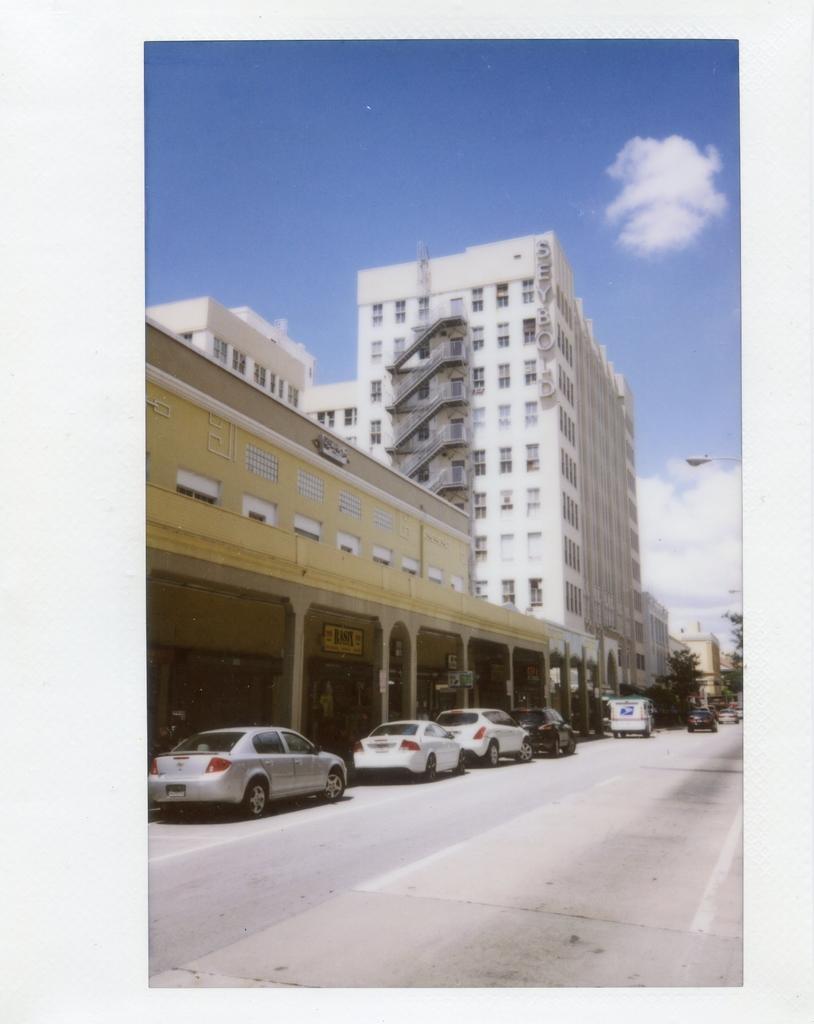Can you describe this image briefly? In this image we can see road, vehicles, trees, buildings, stairs, street light, sky and clouds. 